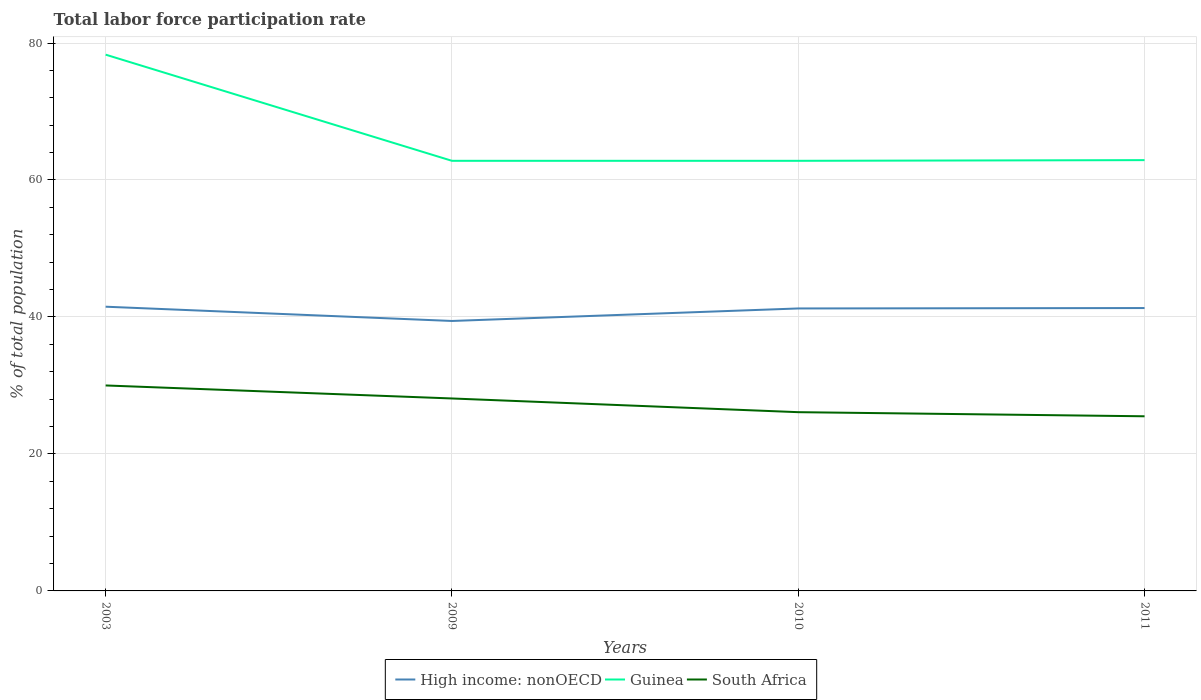Is the number of lines equal to the number of legend labels?
Offer a terse response. Yes. Across all years, what is the maximum total labor force participation rate in South Africa?
Your answer should be very brief. 25.5. What is the total total labor force participation rate in South Africa in the graph?
Provide a short and direct response. 1.9. What is the difference between the highest and the second highest total labor force participation rate in Guinea?
Your answer should be compact. 15.5. Is the total labor force participation rate in High income: nonOECD strictly greater than the total labor force participation rate in South Africa over the years?
Your answer should be compact. No. How many lines are there?
Provide a succinct answer. 3. Are the values on the major ticks of Y-axis written in scientific E-notation?
Make the answer very short. No. Does the graph contain grids?
Your answer should be compact. Yes. How many legend labels are there?
Provide a short and direct response. 3. What is the title of the graph?
Your answer should be very brief. Total labor force participation rate. What is the label or title of the Y-axis?
Your answer should be very brief. % of total population. What is the % of total population in High income: nonOECD in 2003?
Give a very brief answer. 41.5. What is the % of total population of Guinea in 2003?
Give a very brief answer. 78.3. What is the % of total population of High income: nonOECD in 2009?
Provide a short and direct response. 39.42. What is the % of total population in Guinea in 2009?
Give a very brief answer. 62.8. What is the % of total population in South Africa in 2009?
Make the answer very short. 28.1. What is the % of total population of High income: nonOECD in 2010?
Provide a succinct answer. 41.24. What is the % of total population of Guinea in 2010?
Keep it short and to the point. 62.8. What is the % of total population of South Africa in 2010?
Your answer should be very brief. 26.1. What is the % of total population in High income: nonOECD in 2011?
Make the answer very short. 41.3. What is the % of total population of Guinea in 2011?
Your answer should be very brief. 62.9. What is the % of total population of South Africa in 2011?
Provide a short and direct response. 25.5. Across all years, what is the maximum % of total population in High income: nonOECD?
Offer a very short reply. 41.5. Across all years, what is the maximum % of total population of Guinea?
Ensure brevity in your answer.  78.3. Across all years, what is the maximum % of total population of South Africa?
Your answer should be compact. 30. Across all years, what is the minimum % of total population of High income: nonOECD?
Ensure brevity in your answer.  39.42. Across all years, what is the minimum % of total population in Guinea?
Offer a very short reply. 62.8. What is the total % of total population of High income: nonOECD in the graph?
Offer a very short reply. 163.46. What is the total % of total population of Guinea in the graph?
Ensure brevity in your answer.  266.8. What is the total % of total population in South Africa in the graph?
Keep it short and to the point. 109.7. What is the difference between the % of total population of High income: nonOECD in 2003 and that in 2009?
Your answer should be very brief. 2.08. What is the difference between the % of total population of Guinea in 2003 and that in 2009?
Provide a short and direct response. 15.5. What is the difference between the % of total population in South Africa in 2003 and that in 2009?
Your response must be concise. 1.9. What is the difference between the % of total population in High income: nonOECD in 2003 and that in 2010?
Offer a terse response. 0.26. What is the difference between the % of total population in High income: nonOECD in 2003 and that in 2011?
Offer a very short reply. 0.2. What is the difference between the % of total population of Guinea in 2003 and that in 2011?
Provide a succinct answer. 15.4. What is the difference between the % of total population in High income: nonOECD in 2009 and that in 2010?
Your answer should be compact. -1.83. What is the difference between the % of total population of South Africa in 2009 and that in 2010?
Your answer should be compact. 2. What is the difference between the % of total population of High income: nonOECD in 2009 and that in 2011?
Provide a succinct answer. -1.89. What is the difference between the % of total population in Guinea in 2009 and that in 2011?
Provide a succinct answer. -0.1. What is the difference between the % of total population in High income: nonOECD in 2010 and that in 2011?
Your answer should be very brief. -0.06. What is the difference between the % of total population of Guinea in 2010 and that in 2011?
Make the answer very short. -0.1. What is the difference between the % of total population in South Africa in 2010 and that in 2011?
Offer a terse response. 0.6. What is the difference between the % of total population of High income: nonOECD in 2003 and the % of total population of Guinea in 2009?
Offer a terse response. -21.3. What is the difference between the % of total population in High income: nonOECD in 2003 and the % of total population in South Africa in 2009?
Offer a terse response. 13.4. What is the difference between the % of total population in Guinea in 2003 and the % of total population in South Africa in 2009?
Ensure brevity in your answer.  50.2. What is the difference between the % of total population in High income: nonOECD in 2003 and the % of total population in Guinea in 2010?
Provide a short and direct response. -21.3. What is the difference between the % of total population of High income: nonOECD in 2003 and the % of total population of South Africa in 2010?
Offer a very short reply. 15.4. What is the difference between the % of total population of Guinea in 2003 and the % of total population of South Africa in 2010?
Give a very brief answer. 52.2. What is the difference between the % of total population of High income: nonOECD in 2003 and the % of total population of Guinea in 2011?
Provide a succinct answer. -21.4. What is the difference between the % of total population of High income: nonOECD in 2003 and the % of total population of South Africa in 2011?
Offer a very short reply. 16. What is the difference between the % of total population of Guinea in 2003 and the % of total population of South Africa in 2011?
Your response must be concise. 52.8. What is the difference between the % of total population in High income: nonOECD in 2009 and the % of total population in Guinea in 2010?
Give a very brief answer. -23.38. What is the difference between the % of total population in High income: nonOECD in 2009 and the % of total population in South Africa in 2010?
Ensure brevity in your answer.  13.32. What is the difference between the % of total population in Guinea in 2009 and the % of total population in South Africa in 2010?
Keep it short and to the point. 36.7. What is the difference between the % of total population in High income: nonOECD in 2009 and the % of total population in Guinea in 2011?
Give a very brief answer. -23.48. What is the difference between the % of total population of High income: nonOECD in 2009 and the % of total population of South Africa in 2011?
Your response must be concise. 13.92. What is the difference between the % of total population in Guinea in 2009 and the % of total population in South Africa in 2011?
Keep it short and to the point. 37.3. What is the difference between the % of total population in High income: nonOECD in 2010 and the % of total population in Guinea in 2011?
Your response must be concise. -21.66. What is the difference between the % of total population of High income: nonOECD in 2010 and the % of total population of South Africa in 2011?
Your answer should be compact. 15.74. What is the difference between the % of total population of Guinea in 2010 and the % of total population of South Africa in 2011?
Your answer should be very brief. 37.3. What is the average % of total population of High income: nonOECD per year?
Offer a terse response. 40.86. What is the average % of total population of Guinea per year?
Provide a short and direct response. 66.7. What is the average % of total population of South Africa per year?
Offer a very short reply. 27.43. In the year 2003, what is the difference between the % of total population in High income: nonOECD and % of total population in Guinea?
Make the answer very short. -36.8. In the year 2003, what is the difference between the % of total population of High income: nonOECD and % of total population of South Africa?
Offer a terse response. 11.5. In the year 2003, what is the difference between the % of total population in Guinea and % of total population in South Africa?
Provide a short and direct response. 48.3. In the year 2009, what is the difference between the % of total population in High income: nonOECD and % of total population in Guinea?
Make the answer very short. -23.38. In the year 2009, what is the difference between the % of total population of High income: nonOECD and % of total population of South Africa?
Your answer should be compact. 11.32. In the year 2009, what is the difference between the % of total population in Guinea and % of total population in South Africa?
Make the answer very short. 34.7. In the year 2010, what is the difference between the % of total population in High income: nonOECD and % of total population in Guinea?
Your response must be concise. -21.56. In the year 2010, what is the difference between the % of total population of High income: nonOECD and % of total population of South Africa?
Provide a short and direct response. 15.14. In the year 2010, what is the difference between the % of total population of Guinea and % of total population of South Africa?
Offer a very short reply. 36.7. In the year 2011, what is the difference between the % of total population of High income: nonOECD and % of total population of Guinea?
Your response must be concise. -21.6. In the year 2011, what is the difference between the % of total population in High income: nonOECD and % of total population in South Africa?
Provide a short and direct response. 15.8. In the year 2011, what is the difference between the % of total population of Guinea and % of total population of South Africa?
Offer a terse response. 37.4. What is the ratio of the % of total population in High income: nonOECD in 2003 to that in 2009?
Your answer should be very brief. 1.05. What is the ratio of the % of total population in Guinea in 2003 to that in 2009?
Provide a succinct answer. 1.25. What is the ratio of the % of total population of South Africa in 2003 to that in 2009?
Offer a terse response. 1.07. What is the ratio of the % of total population of High income: nonOECD in 2003 to that in 2010?
Make the answer very short. 1.01. What is the ratio of the % of total population of Guinea in 2003 to that in 2010?
Make the answer very short. 1.25. What is the ratio of the % of total population of South Africa in 2003 to that in 2010?
Provide a succinct answer. 1.15. What is the ratio of the % of total population of High income: nonOECD in 2003 to that in 2011?
Keep it short and to the point. 1. What is the ratio of the % of total population of Guinea in 2003 to that in 2011?
Your response must be concise. 1.24. What is the ratio of the % of total population of South Africa in 2003 to that in 2011?
Ensure brevity in your answer.  1.18. What is the ratio of the % of total population of High income: nonOECD in 2009 to that in 2010?
Your answer should be compact. 0.96. What is the ratio of the % of total population in Guinea in 2009 to that in 2010?
Provide a succinct answer. 1. What is the ratio of the % of total population of South Africa in 2009 to that in 2010?
Give a very brief answer. 1.08. What is the ratio of the % of total population of High income: nonOECD in 2009 to that in 2011?
Provide a succinct answer. 0.95. What is the ratio of the % of total population of South Africa in 2009 to that in 2011?
Give a very brief answer. 1.1. What is the ratio of the % of total population of Guinea in 2010 to that in 2011?
Provide a short and direct response. 1. What is the ratio of the % of total population in South Africa in 2010 to that in 2011?
Give a very brief answer. 1.02. What is the difference between the highest and the second highest % of total population of High income: nonOECD?
Offer a terse response. 0.2. What is the difference between the highest and the lowest % of total population of High income: nonOECD?
Give a very brief answer. 2.08. What is the difference between the highest and the lowest % of total population in South Africa?
Offer a very short reply. 4.5. 